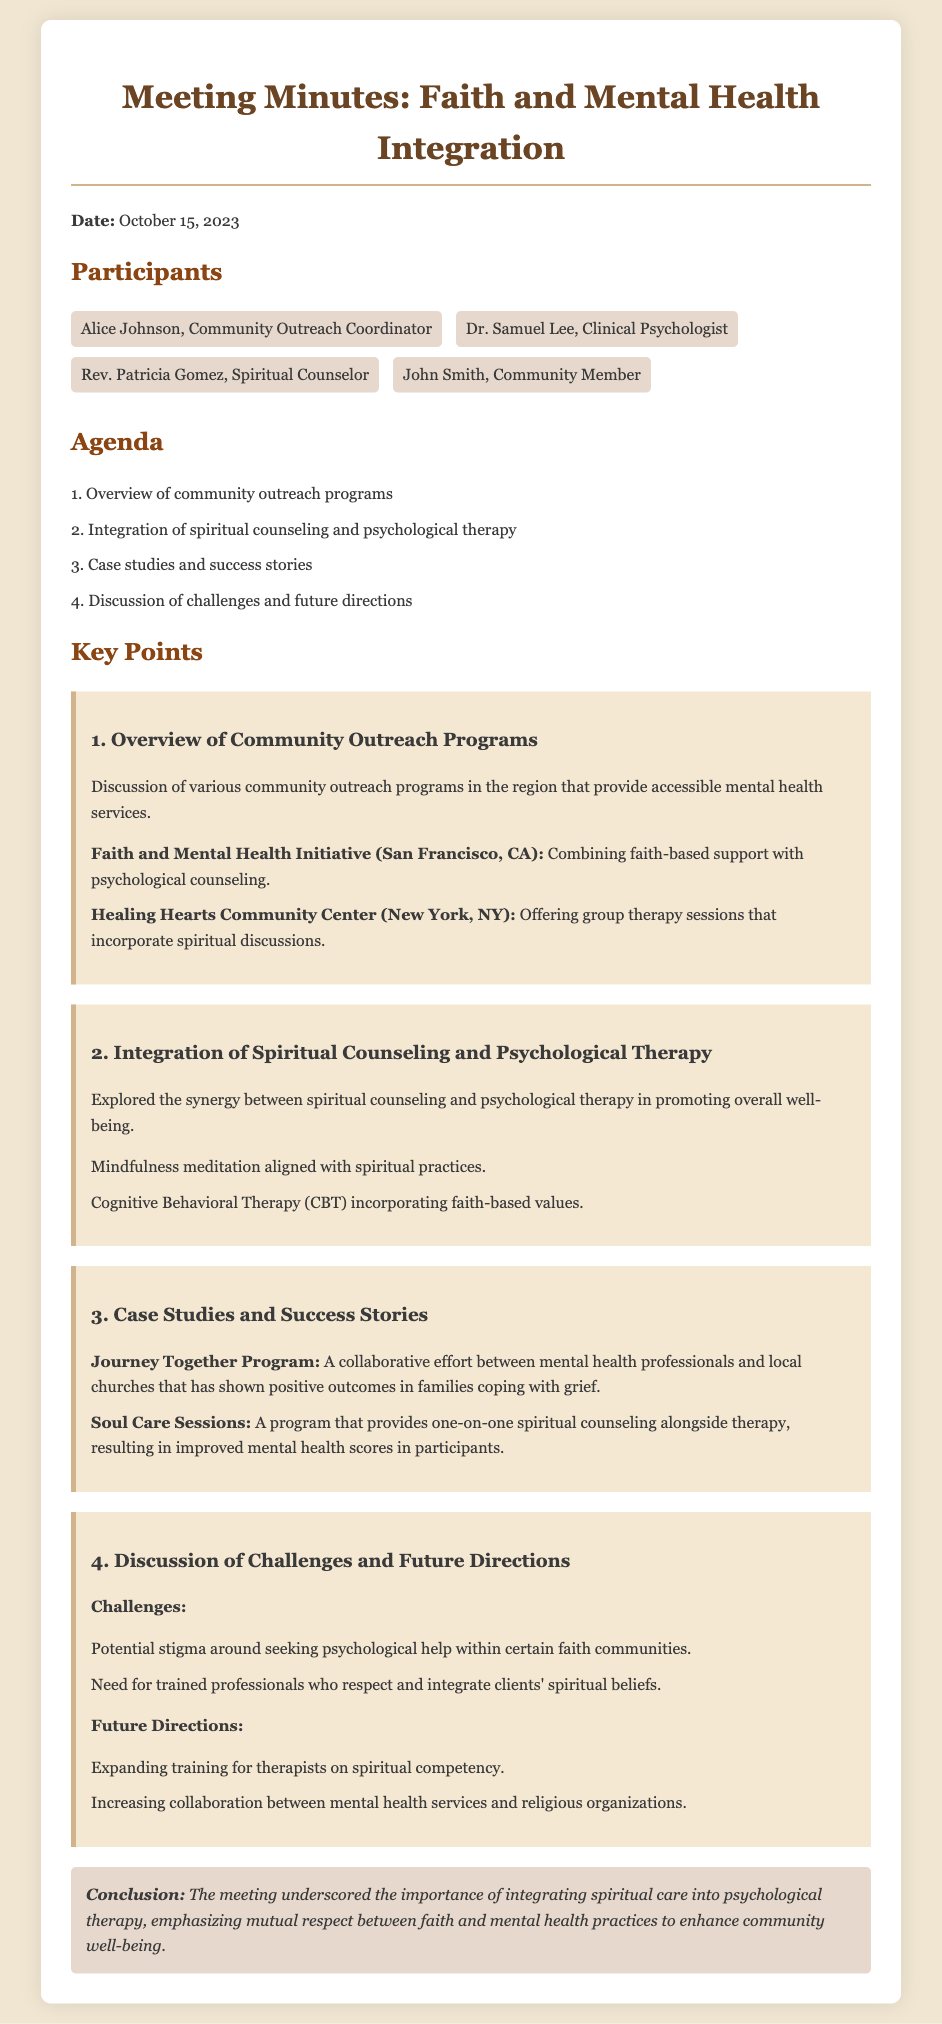What is the date of the meeting? The date of the meeting is stated at the beginning of the document as October 15, 2023.
Answer: October 15, 2023 Who is the Community Outreach Coordinator? The document lists Alice Johnson as the Community Outreach Coordinator among the participants.
Answer: Alice Johnson What is the name of the program that combines faith-based support with psychological counseling? The document specifically mentions the Faith and Mental Health Initiative as a program combining these elements.
Answer: Faith and Mental Health Initiative What are the two approaches explored for integrating spiritual counseling and psychological therapy? The document lists mindfulness meditation and Cognitive Behavioral Therapy as approaches explored for integration.
Answer: Mindfulness meditation and Cognitive Behavioral Therapy What challenge is mentioned regarding seeking psychological help in faith communities? The document notes potential stigma around seeking psychological help as a challenge in certain faith communities.
Answer: Stigma What is one of the future directions discussed for mental health services? The document mentions expanding training for therapists on spiritual competency as a future direction.
Answer: Expanding training for therapists What type of program is "Journey Together Program"? The document describes the Journey Together Program as a collaborative effort between mental health professionals and local churches.
Answer: Collaborative effort What does the conclusion emphasize about integrating spiritual care into therapy? The conclusion indicates the meeting underscored the importance of mutual respect between faith and mental health practices.
Answer: Mutual respect 